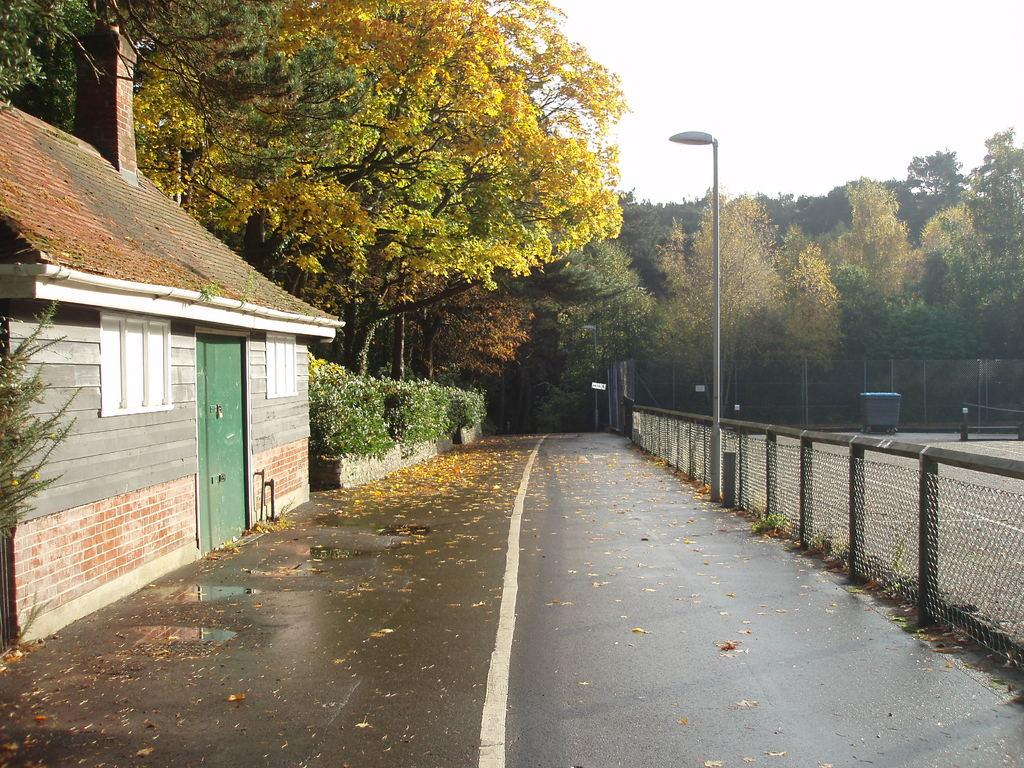What is covering the road in the image? There are leaves on the road. What type of structure can be seen in the image? There is a house in the image. What type of vegetation is present in the image? There are trees in the image. What type of barrier is visible in the image? There is a fence in the image. What type of container is present in the court? There is a bin in the court. What type of lighting fixture is visible in the image? There is a street light in the image. What part of the natural environment is visible in the image? The sky is visible in the image. What type of hat is the earth wearing in the image? There is no hat or representation of the earth present in the image. What time of day is depicted in the image? The provided facts do not mention the time of day, so it cannot be determined from the image. 